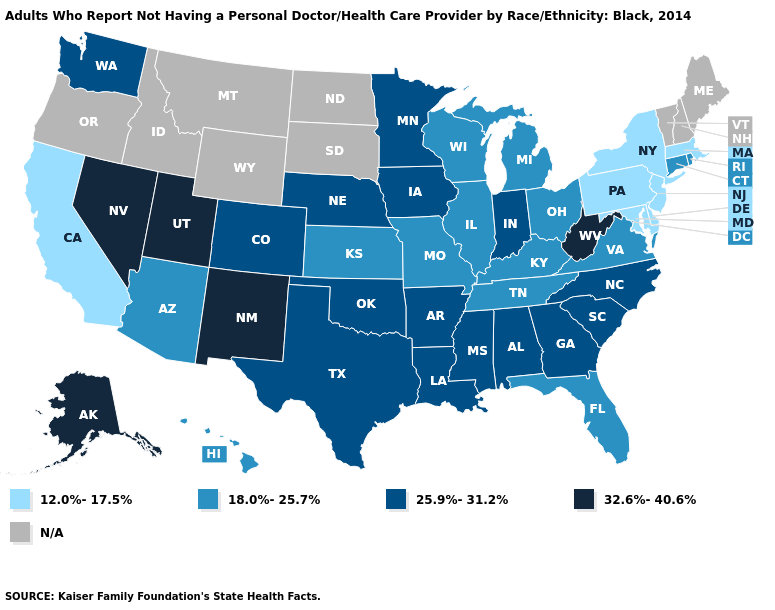What is the lowest value in the South?
Give a very brief answer. 12.0%-17.5%. Does the first symbol in the legend represent the smallest category?
Quick response, please. Yes. Which states hav the highest value in the South?
Quick response, please. West Virginia. Name the states that have a value in the range 18.0%-25.7%?
Be succinct. Arizona, Connecticut, Florida, Hawaii, Illinois, Kansas, Kentucky, Michigan, Missouri, Ohio, Rhode Island, Tennessee, Virginia, Wisconsin. How many symbols are there in the legend?
Keep it brief. 5. Does Utah have the lowest value in the West?
Be succinct. No. Is the legend a continuous bar?
Quick response, please. No. Among the states that border Kentucky , which have the highest value?
Short answer required. West Virginia. Name the states that have a value in the range 25.9%-31.2%?
Be succinct. Alabama, Arkansas, Colorado, Georgia, Indiana, Iowa, Louisiana, Minnesota, Mississippi, Nebraska, North Carolina, Oklahoma, South Carolina, Texas, Washington. Name the states that have a value in the range N/A?
Answer briefly. Idaho, Maine, Montana, New Hampshire, North Dakota, Oregon, South Dakota, Vermont, Wyoming. What is the value of Michigan?
Keep it brief. 18.0%-25.7%. Name the states that have a value in the range 12.0%-17.5%?
Answer briefly. California, Delaware, Maryland, Massachusetts, New Jersey, New York, Pennsylvania. 